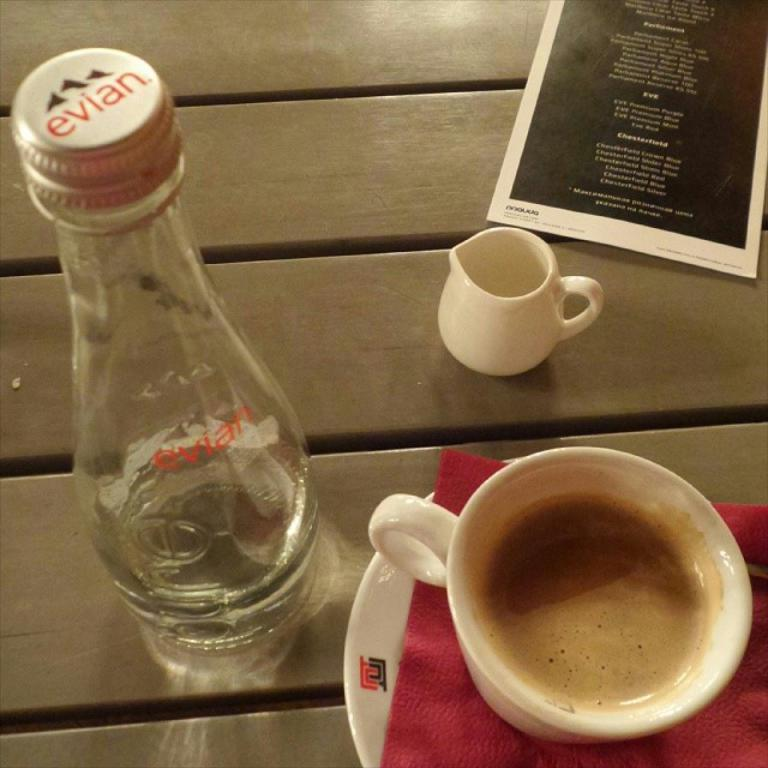What is in the tea cup that is visible in the image? There is a tea cup with tea in the image. How is the tea cup positioned on the table? The tea cup is in a saucer. What other objects can be seen on the table in the image? There is a bottle, a paper, and an empty cup in the image. What is the value of the oven in the image? There is no oven present in the image, so it is not possible to determine its value. 